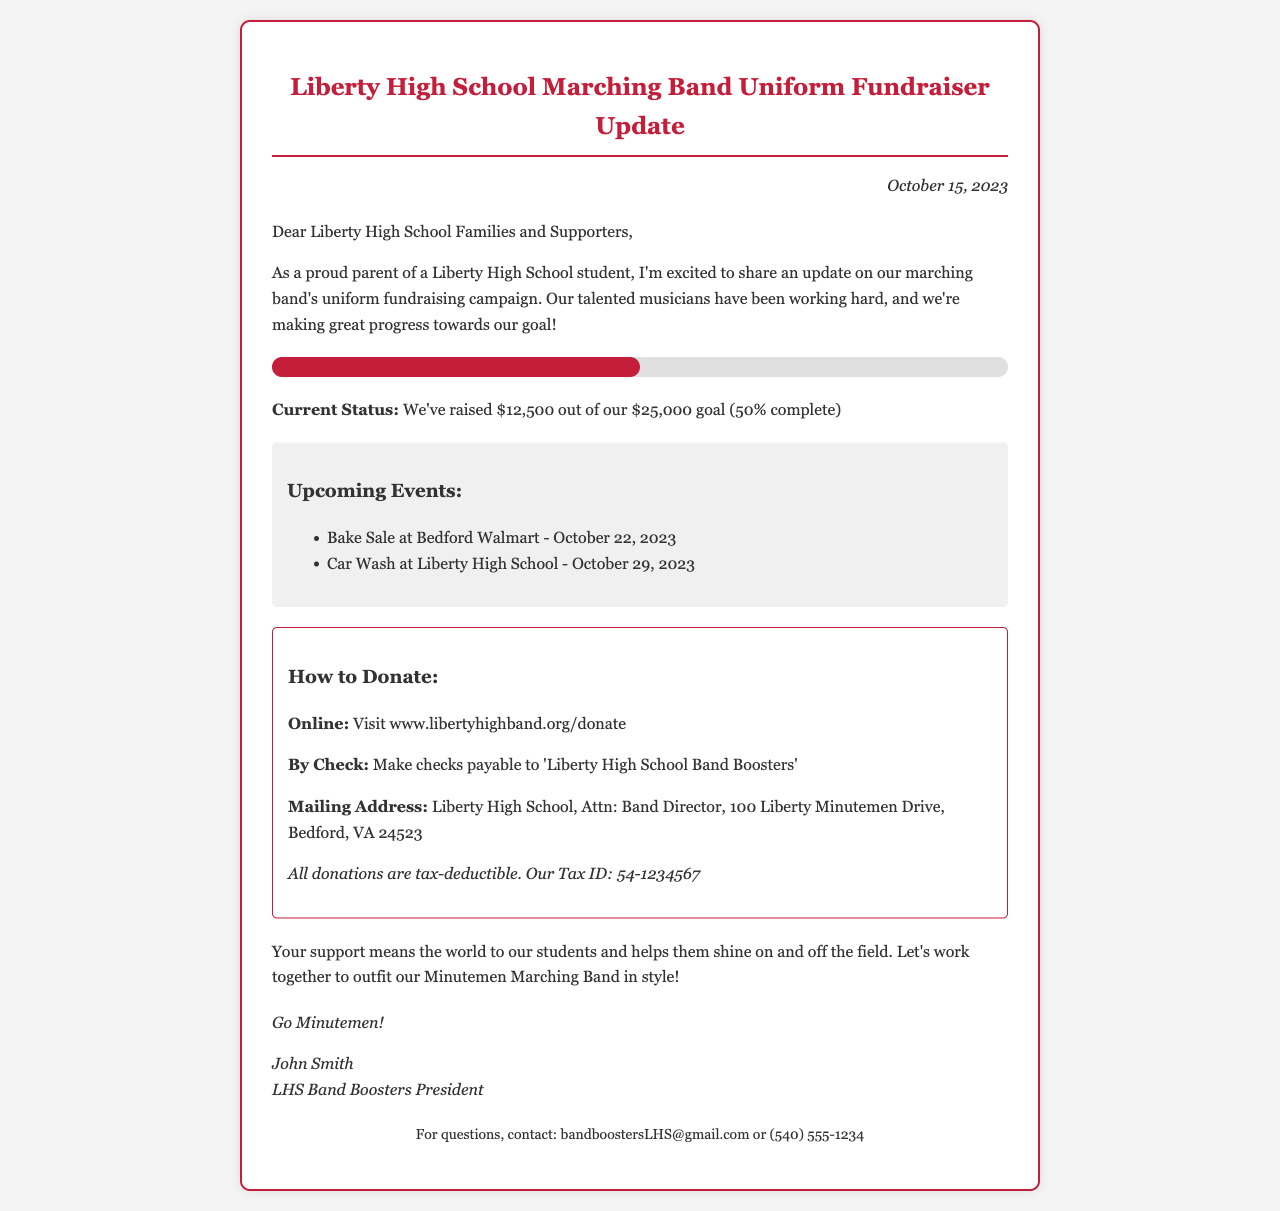What is the fundraising goal? The fundraising goal is stated in the document as $25,000.
Answer: $25,000 How much has been raised so far? The document indicates that $12,500 has been raised to date.
Answer: $12,500 What date is the Bake Sale scheduled for? The Bake Sale event is scheduled for October 22, 2023.
Answer: October 22, 2023 Who is the president of the Band Boosters? The document lists John Smith as the Band Boosters President.
Answer: John Smith What is the Tax ID number mentioned in the document? The Tax ID provided in the document is 54-1234567.
Answer: 54-1234567 What percentage of the goal has been reached? The document states that 50% of the goal has been reached.
Answer: 50% What is the mailing address for donations? The document specifies the mailing address for donations as Liberty High School, Attn: Band Director, 100 Liberty Minutemen Drive, Bedford, VA 24523.
Answer: Liberty High School, Attn: Band Director, 100 Liberty Minutemen Drive, Bedford, VA 24523 What kind of support is being requested? The document seeks monetary donations to support the marching band's uniforms.
Answer: Monetary donations How can donations be made online? The document provides a website for online donations at www.libertyhighband.org/donate.
Answer: www.libertyhighband.org/donate 